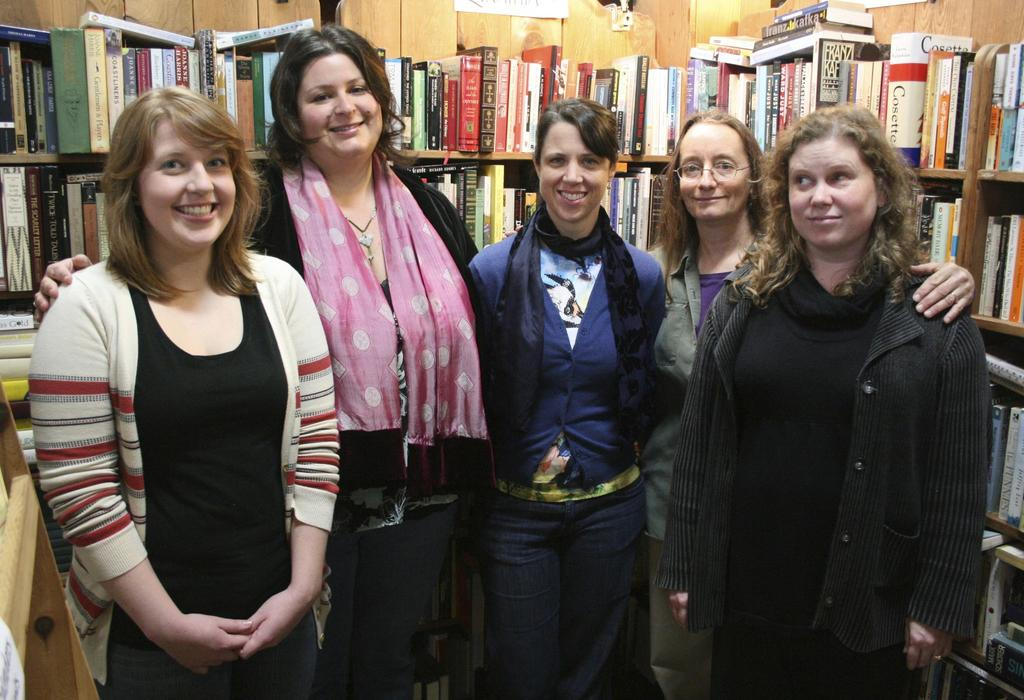How many people are present in the image? There are people in the image, but the exact number is not specified. Can you describe any specific features of one of the people? One person is wearing spectacles. What can be seen in the background of the image? There are books in the background of the image, stored in racks. How many cows are visible in the image? There are no cows present in the image. What type of porter is assisting the people in the image? There is no porter present in the image. 